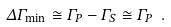<formula> <loc_0><loc_0><loc_500><loc_500>\Delta \Gamma _ { \min } \cong \Gamma _ { P } - \Gamma _ { S } \cong \Gamma _ { P } \ .</formula> 